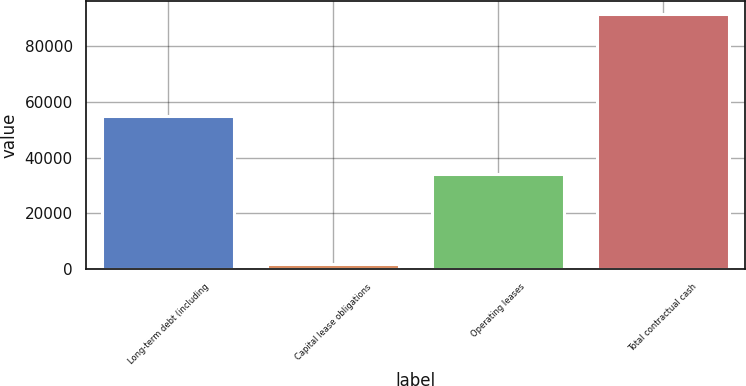Convert chart to OTSL. <chart><loc_0><loc_0><loc_500><loc_500><bar_chart><fcel>Long-term debt (including<fcel>Capital lease obligations<fcel>Operating leases<fcel>Total contractual cash<nl><fcel>55000<fcel>1807<fcel>34261<fcel>91415<nl></chart> 